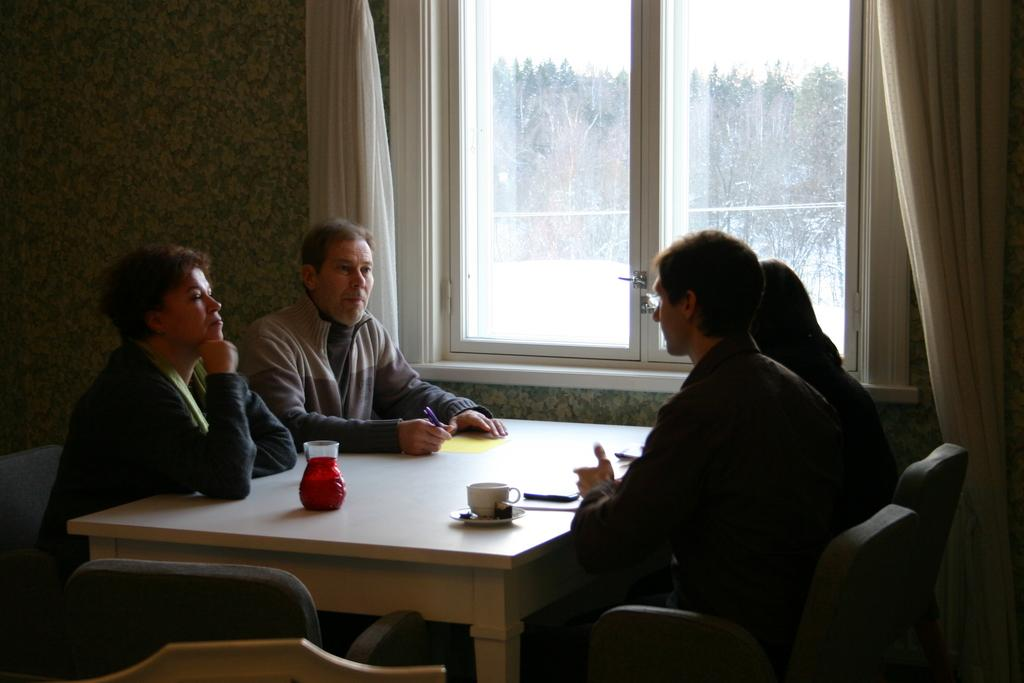What is happening in the image involving a group of people? There is a group of people in the image, and they are seated on chairs. What objects can be seen on the table in the image? There is a teacup and a glass on the table in the image. What type of window treatment is present in the image? There are curtains near a window in the image. What type of ink is being used to write on the table in the image? There is no ink or writing present on the table in the image. What is the angle of the slope in the image? There is no slope present in the image. 